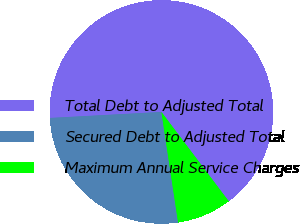<chart> <loc_0><loc_0><loc_500><loc_500><pie_chart><fcel>Total Debt to Adjusted Total<fcel>Secured Debt to Adjusted Total<fcel>Maximum Annual Service Charges<nl><fcel>65.57%<fcel>26.53%<fcel>7.9%<nl></chart> 